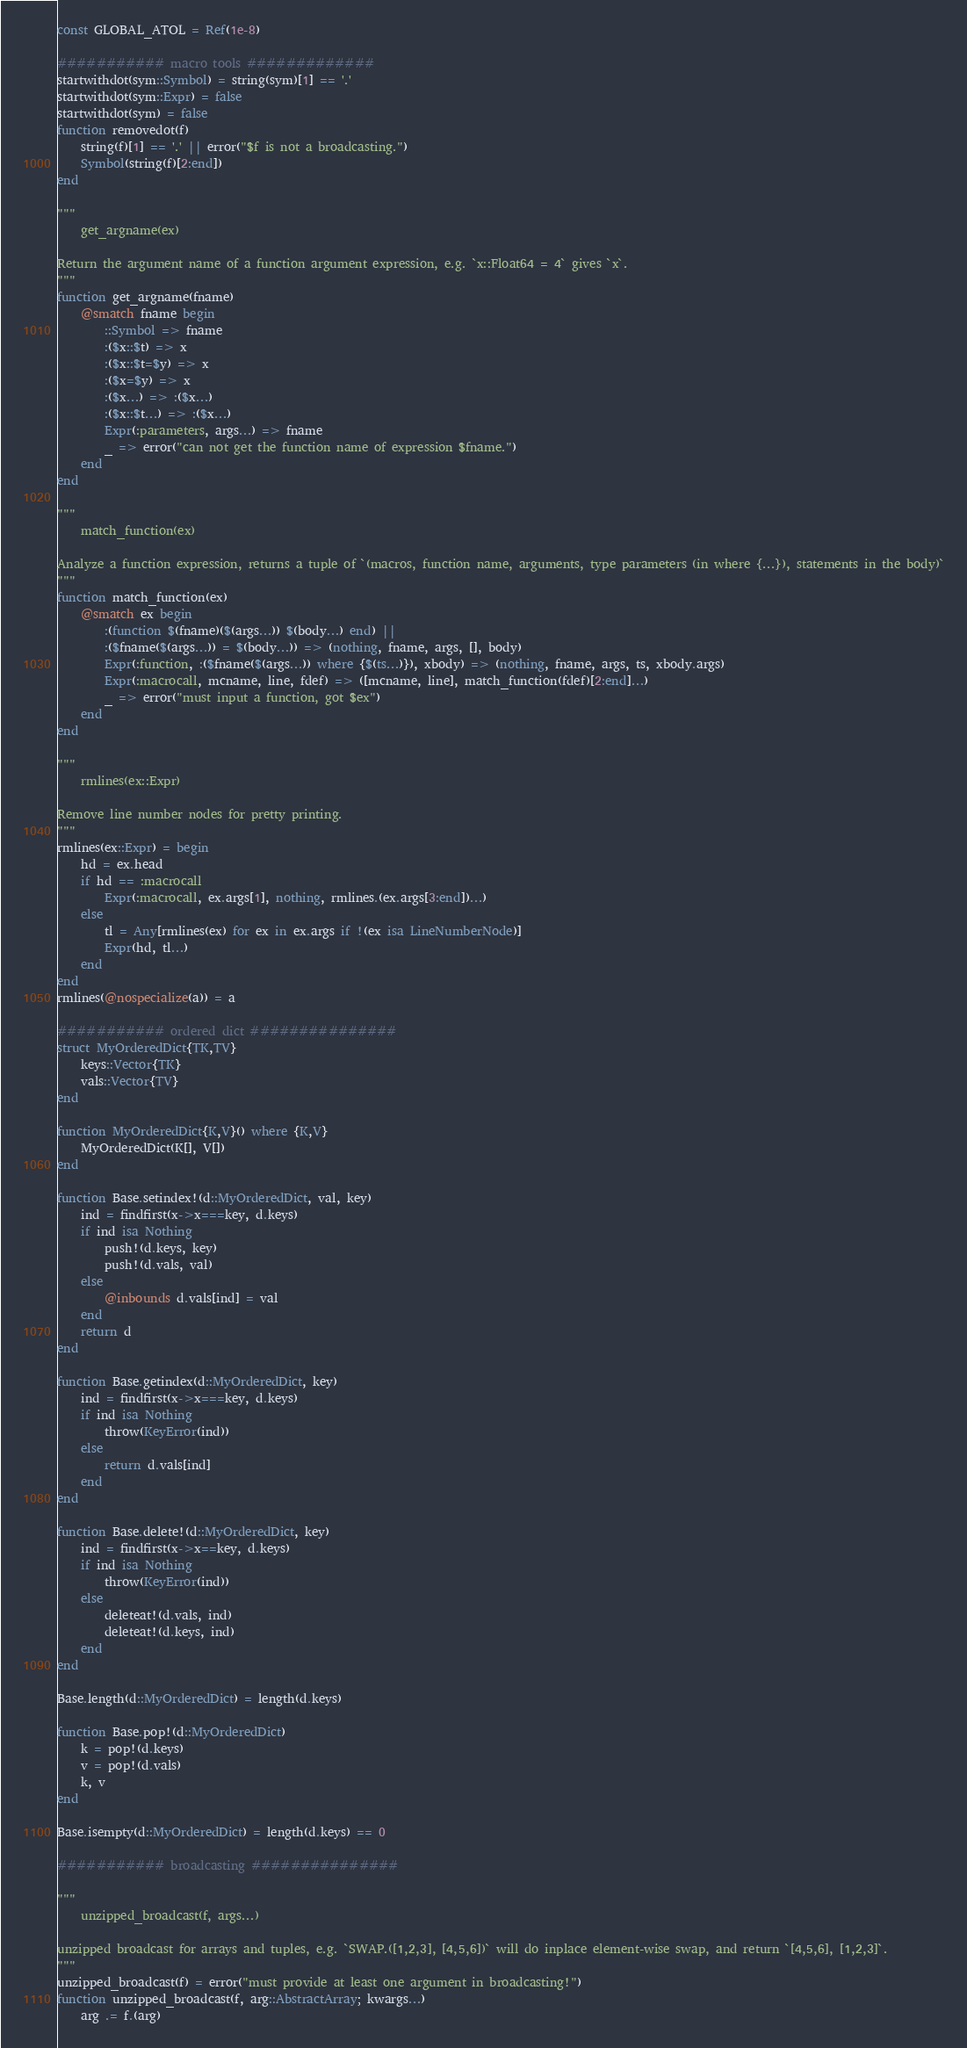<code> <loc_0><loc_0><loc_500><loc_500><_Julia_>const GLOBAL_ATOL = Ref(1e-8)

########### macro tools #############
startwithdot(sym::Symbol) = string(sym)[1] == '.'
startwithdot(sym::Expr) = false
startwithdot(sym) = false
function removedot(f)
    string(f)[1] == '.' || error("$f is not a broadcasting.")
    Symbol(string(f)[2:end])
end

"""
    get_argname(ex)

Return the argument name of a function argument expression, e.g. `x::Float64 = 4` gives `x`.
"""
function get_argname(fname)
    @smatch fname begin
        ::Symbol => fname
        :($x::$t) => x
        :($x::$t=$y) => x
        :($x=$y) => x
        :($x...) => :($x...)
        :($x::$t...) => :($x...)
        Expr(:parameters, args...) => fname
        _ => error("can not get the function name of expression $fname.")
    end
end

"""
    match_function(ex)

Analyze a function expression, returns a tuple of `(macros, function name, arguments, type parameters (in where {...}), statements in the body)`
"""
function match_function(ex)
    @smatch ex begin
        :(function $(fname)($(args...)) $(body...) end) ||
        :($fname($(args...)) = $(body...)) => (nothing, fname, args, [], body)
        Expr(:function, :($fname($(args...)) where {$(ts...)}), xbody) => (nothing, fname, args, ts, xbody.args)
        Expr(:macrocall, mcname, line, fdef) => ([mcname, line], match_function(fdef)[2:end]...)
        _ => error("must input a function, got $ex")
    end
end

"""
    rmlines(ex::Expr)

Remove line number nodes for pretty printing.
"""
rmlines(ex::Expr) = begin
    hd = ex.head
    if hd == :macrocall
        Expr(:macrocall, ex.args[1], nothing, rmlines.(ex.args[3:end])...)
    else
        tl = Any[rmlines(ex) for ex in ex.args if !(ex isa LineNumberNode)]
        Expr(hd, tl...)
    end
end
rmlines(@nospecialize(a)) = a

########### ordered dict ###############
struct MyOrderedDict{TK,TV}
    keys::Vector{TK}
    vals::Vector{TV}
end

function MyOrderedDict{K,V}() where {K,V}
    MyOrderedDict(K[], V[])
end

function Base.setindex!(d::MyOrderedDict, val, key)
    ind = findfirst(x->x===key, d.keys)
    if ind isa Nothing
        push!(d.keys, key)
        push!(d.vals, val)
    else
        @inbounds d.vals[ind] = val
    end
    return d
end

function Base.getindex(d::MyOrderedDict, key)
    ind = findfirst(x->x===key, d.keys)
    if ind isa Nothing
        throw(KeyError(ind))
    else
        return d.vals[ind]
    end
end

function Base.delete!(d::MyOrderedDict, key)
    ind = findfirst(x->x==key, d.keys)
    if ind isa Nothing
        throw(KeyError(ind))
    else
        deleteat!(d.vals, ind)
        deleteat!(d.keys, ind)
    end
end

Base.length(d::MyOrderedDict) = length(d.keys)

function Base.pop!(d::MyOrderedDict)
    k = pop!(d.keys)
    v = pop!(d.vals)
    k, v
end

Base.isempty(d::MyOrderedDict) = length(d.keys) == 0

########### broadcasting ###############

"""
    unzipped_broadcast(f, args...)

unzipped broadcast for arrays and tuples, e.g. `SWAP.([1,2,3], [4,5,6])` will do inplace element-wise swap, and return `[4,5,6], [1,2,3]`.
"""
unzipped_broadcast(f) = error("must provide at least one argument in broadcasting!")
function unzipped_broadcast(f, arg::AbstractArray; kwargs...)
    arg .= f.(arg)</code> 